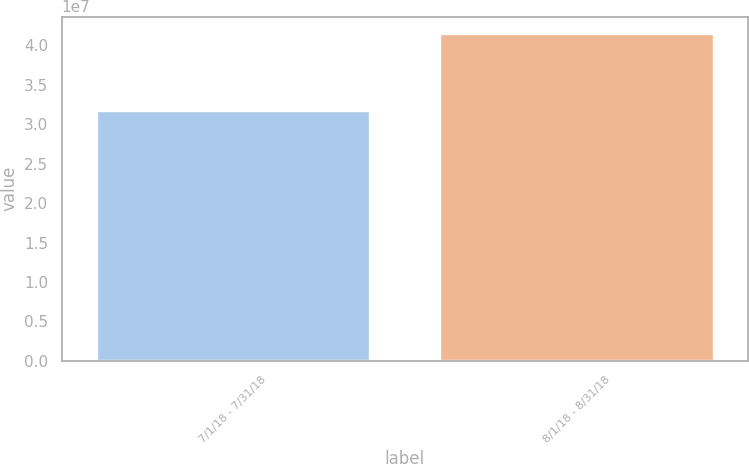Convert chart to OTSL. <chart><loc_0><loc_0><loc_500><loc_500><bar_chart><fcel>7/1/18 - 7/31/18<fcel>8/1/18 - 8/31/18<nl><fcel>3.18554e+07<fcel>4.15696e+07<nl></chart> 